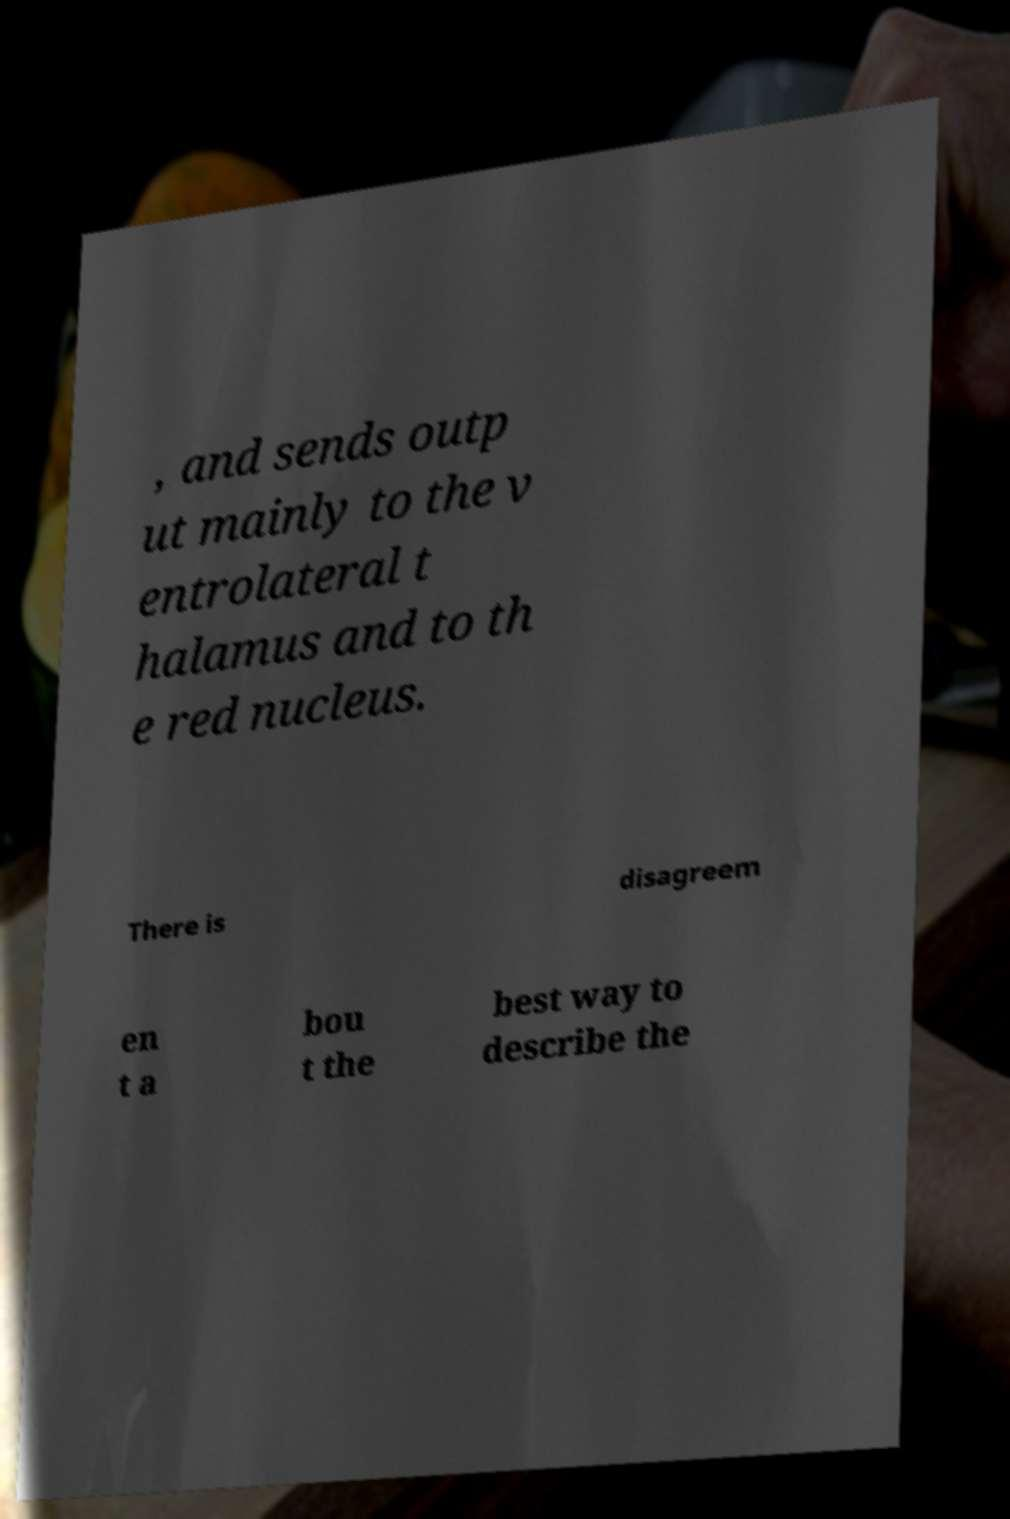What messages or text are displayed in this image? I need them in a readable, typed format. , and sends outp ut mainly to the v entrolateral t halamus and to th e red nucleus. There is disagreem en t a bou t the best way to describe the 